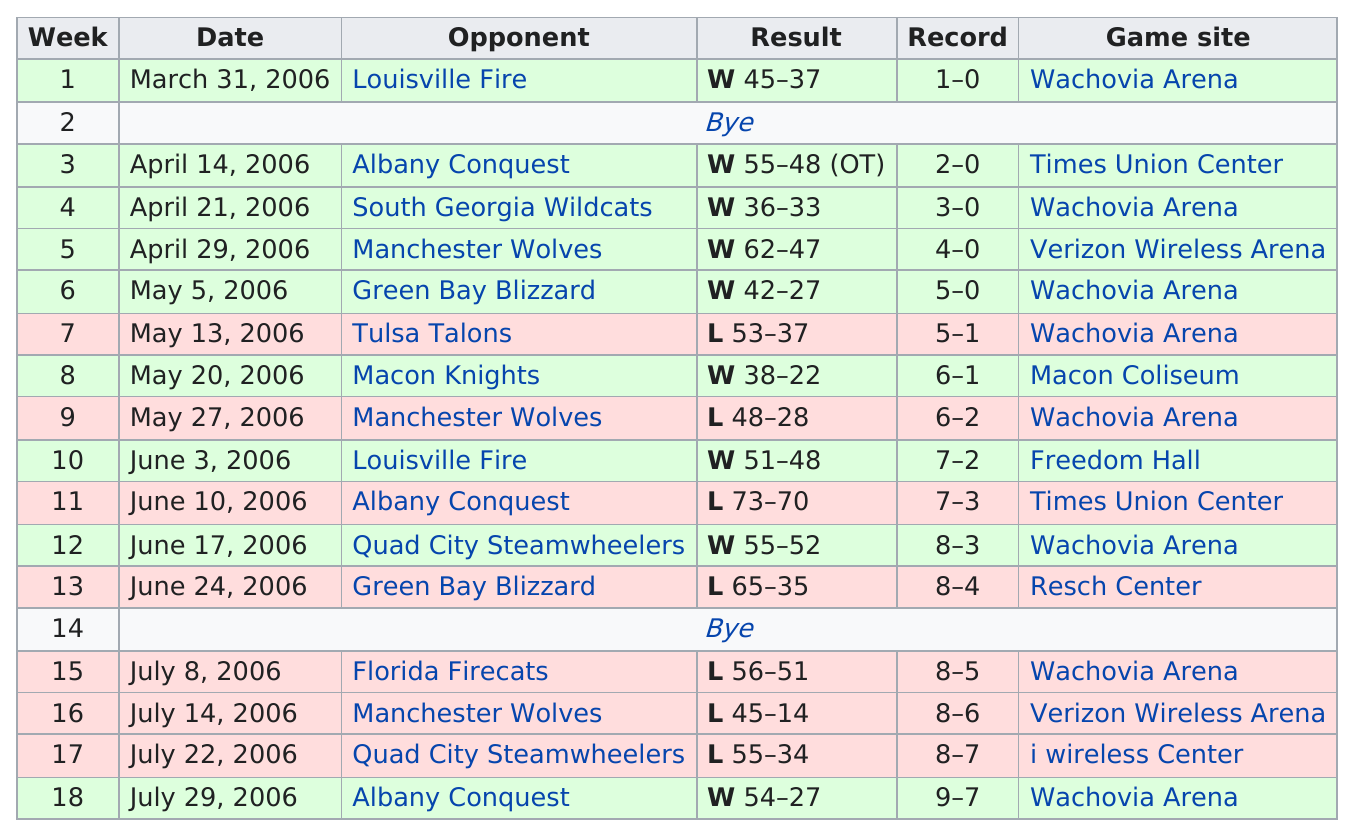Indicate a few pertinent items in this graphic. The location of the game after the game was held at the iWireless Center. However, the Wachovia Arena was also used as a venue for the game. Week 9 or week 11 had a larger gap in score between the two teams, with the difference in score being greater in one of the weeks. The Pioneers defeated the Green Bay Blizzard on May 5th, but ultimately lost to them in a game that occurred on June 24, 2006. The first loss that the team had during the season resulted in a score of 53-37. The opponent in the last game played was the Albany Conquest. 